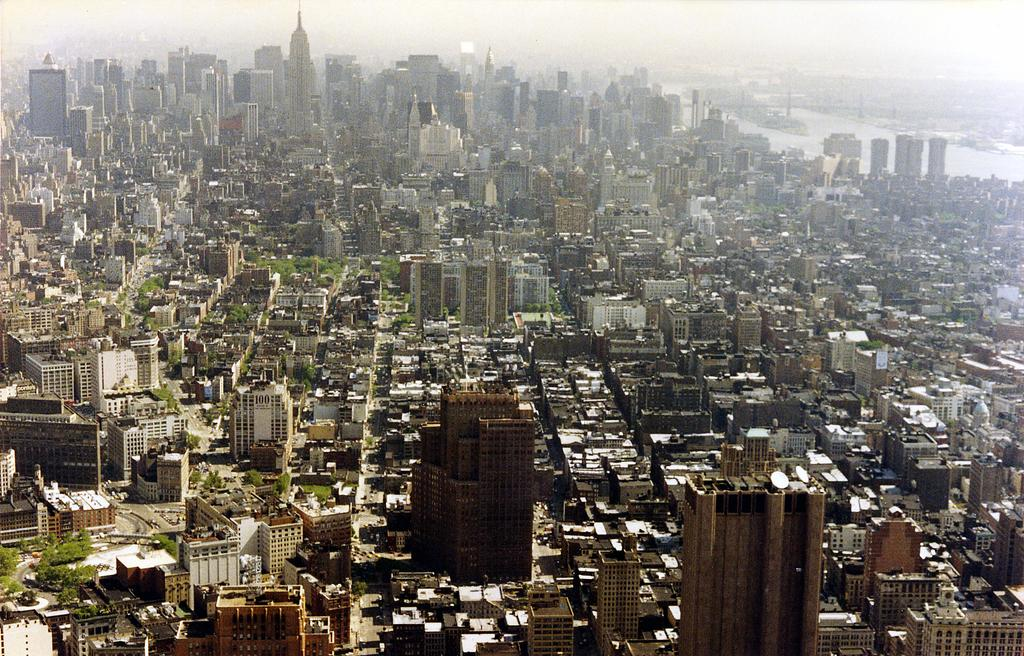What type of structures can be seen in the image? There are houses, buildings, and towers in the image. What type of vegetation is present in the image? There is grass and trees in the image. What body of water is visible in the image? There is a lake in the image. What is visible in the sky in the image? The sky is visible in the image. When was the image taken? The image was taken during the day. What type of clover can be seen growing near the lake in the image? There is no clover visible in the image. What type of wire is holding up the towers in the image? There is no wire holding up the towers in the image; they are likely supported by their own structures. 